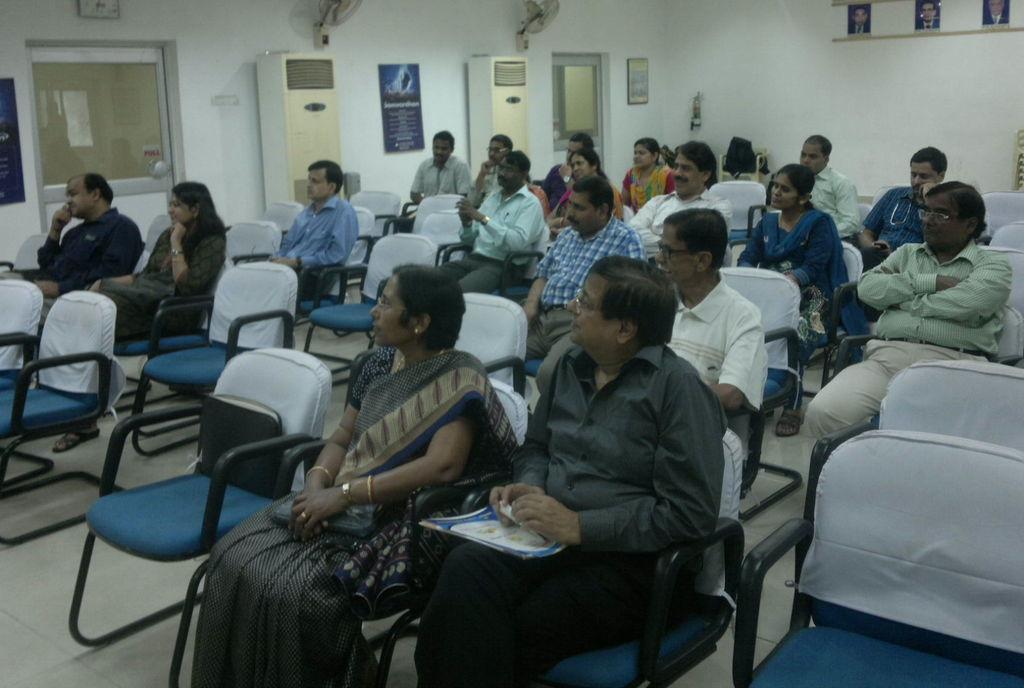In one or two sentences, can you explain what this image depicts? In this image, there are group of people sitting on the chair and listening. In the top, a wall is white in color and a photos are on the wall. Next to that the door is visible here and here. On top of that wall clock is mounted and two pedestal fans are mounted. It seems as if the image is taken inside a hall. 